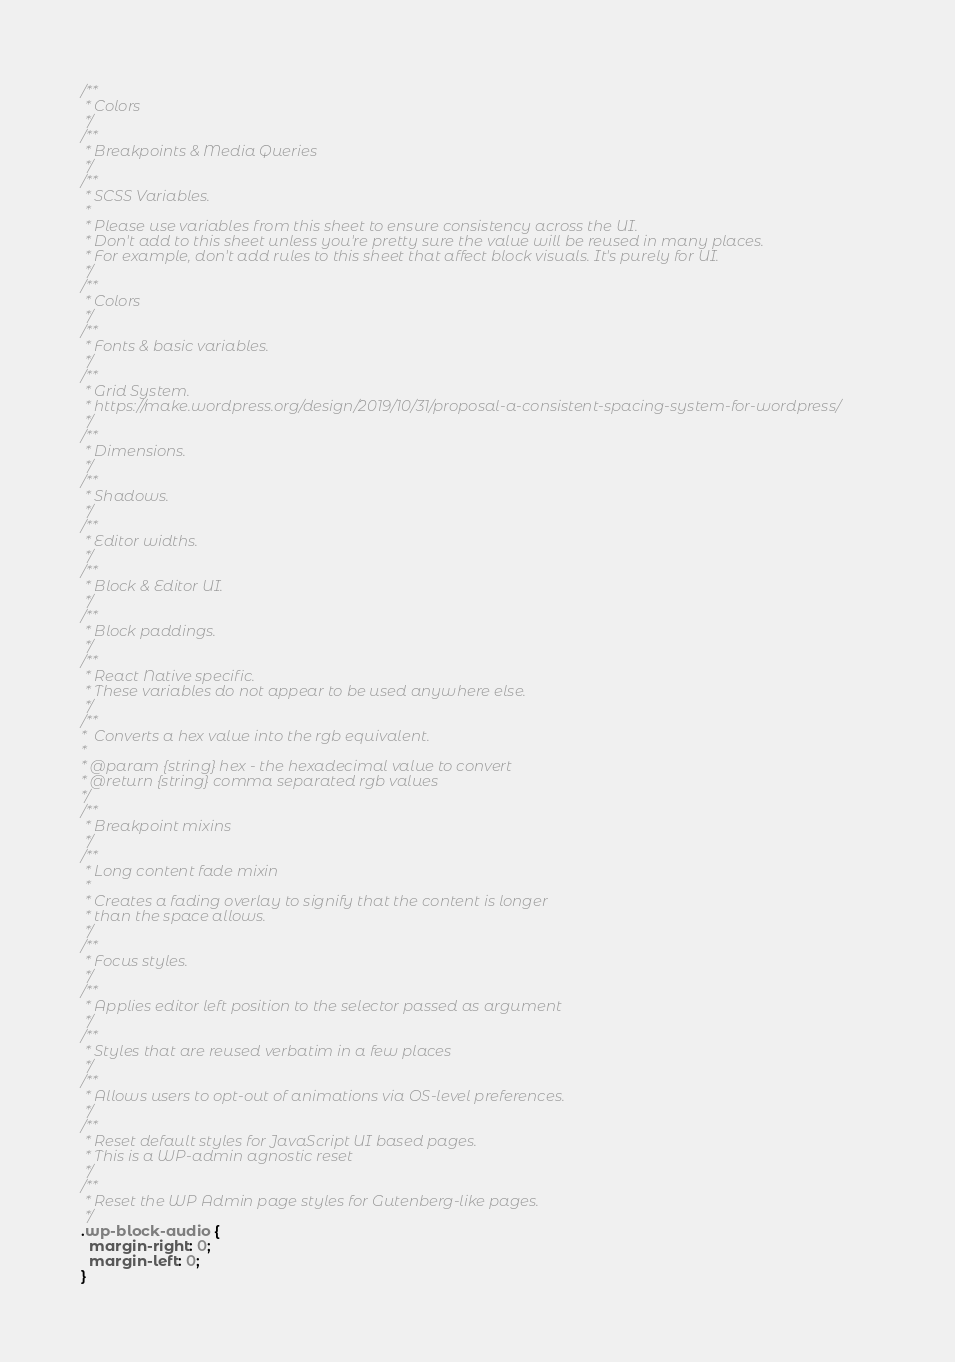Convert code to text. <code><loc_0><loc_0><loc_500><loc_500><_CSS_>/**
 * Colors
 */
/**
 * Breakpoints & Media Queries
 */
/**
 * SCSS Variables.
 *
 * Please use variables from this sheet to ensure consistency across the UI.
 * Don't add to this sheet unless you're pretty sure the value will be reused in many places.
 * For example, don't add rules to this sheet that affect block visuals. It's purely for UI.
 */
/**
 * Colors
 */
/**
 * Fonts & basic variables.
 */
/**
 * Grid System.
 * https://make.wordpress.org/design/2019/10/31/proposal-a-consistent-spacing-system-for-wordpress/
 */
/**
 * Dimensions.
 */
/**
 * Shadows.
 */
/**
 * Editor widths.
 */
/**
 * Block & Editor UI.
 */
/**
 * Block paddings.
 */
/**
 * React Native specific.
 * These variables do not appear to be used anywhere else.
 */
/**
*  Converts a hex value into the rgb equivalent.
*
* @param {string} hex - the hexadecimal value to convert
* @return {string} comma separated rgb values
*/
/**
 * Breakpoint mixins
 */
/**
 * Long content fade mixin
 *
 * Creates a fading overlay to signify that the content is longer
 * than the space allows.
 */
/**
 * Focus styles.
 */
/**
 * Applies editor left position to the selector passed as argument
 */
/**
 * Styles that are reused verbatim in a few places
 */
/**
 * Allows users to opt-out of animations via OS-level preferences.
 */
/**
 * Reset default styles for JavaScript UI based pages.
 * This is a WP-admin agnostic reset
 */
/**
 * Reset the WP Admin page styles for Gutenberg-like pages.
 */
.wp-block-audio {
  margin-right: 0;
  margin-left: 0;
}</code> 